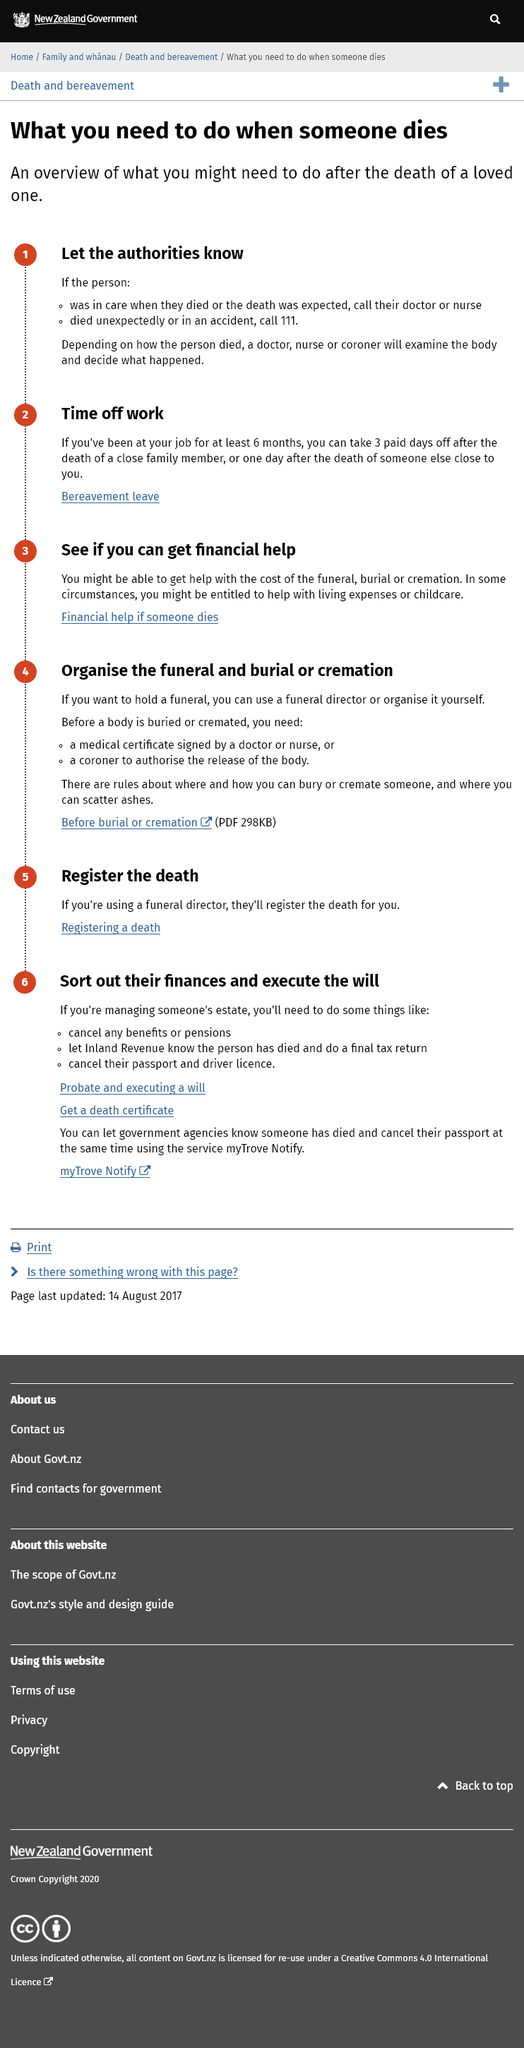Mention a couple of crucial points in this snapshot. The first thing that one should do when someone dies is to notify the authorities. It is necessary to have been employed at a job for at least six months in order to be granted time off work in the event of a death. Bereavement leave refers to the period of time taken off work following the death of a close family member or someone else who is considered close to the individual, as a way of coping with the loss and providing support during a difficult time. 